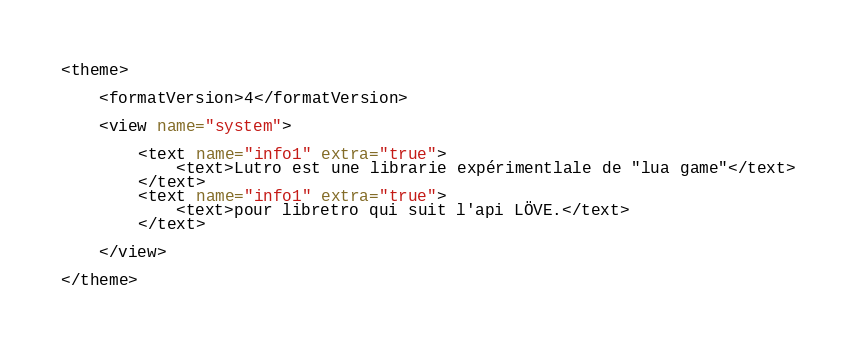Convert code to text. <code><loc_0><loc_0><loc_500><loc_500><_XML_><theme>

	<formatVersion>4</formatVersion>

	<view name="system">
	
		<text name="info1" extra="true">
			<text>Lutro est une librarie expérimentlale de "lua game"</text>
		</text>
		<text name="info1" extra="true">
			<text>pour libretro qui suit l'api LÖVE.</text>
		</text>
		
	</view>
	
</theme>
</code> 